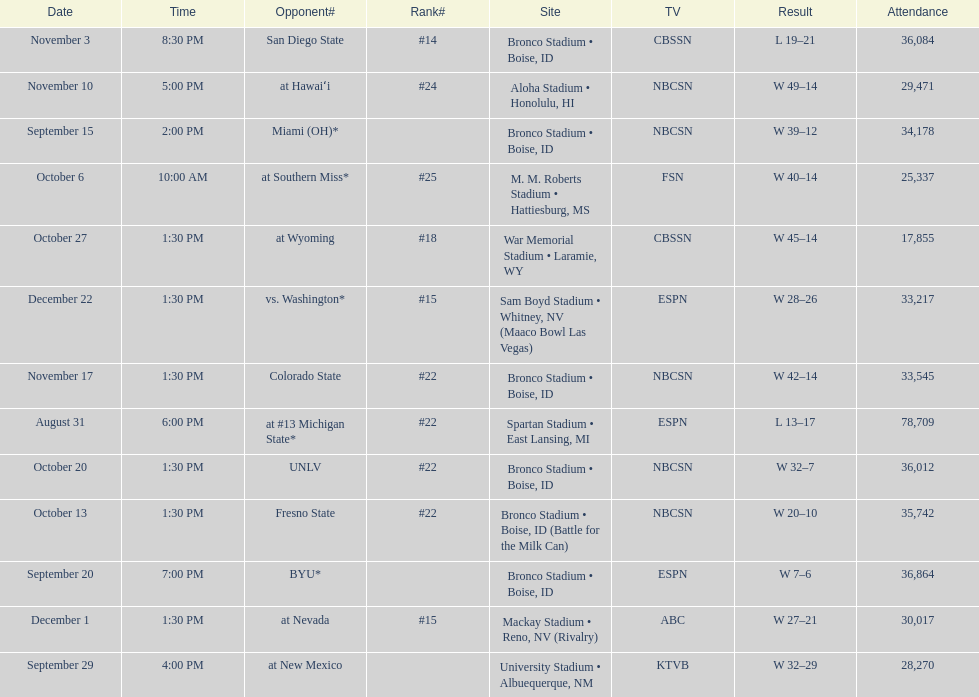Did the broncos on september 29th win by less than 5 points? Yes. 